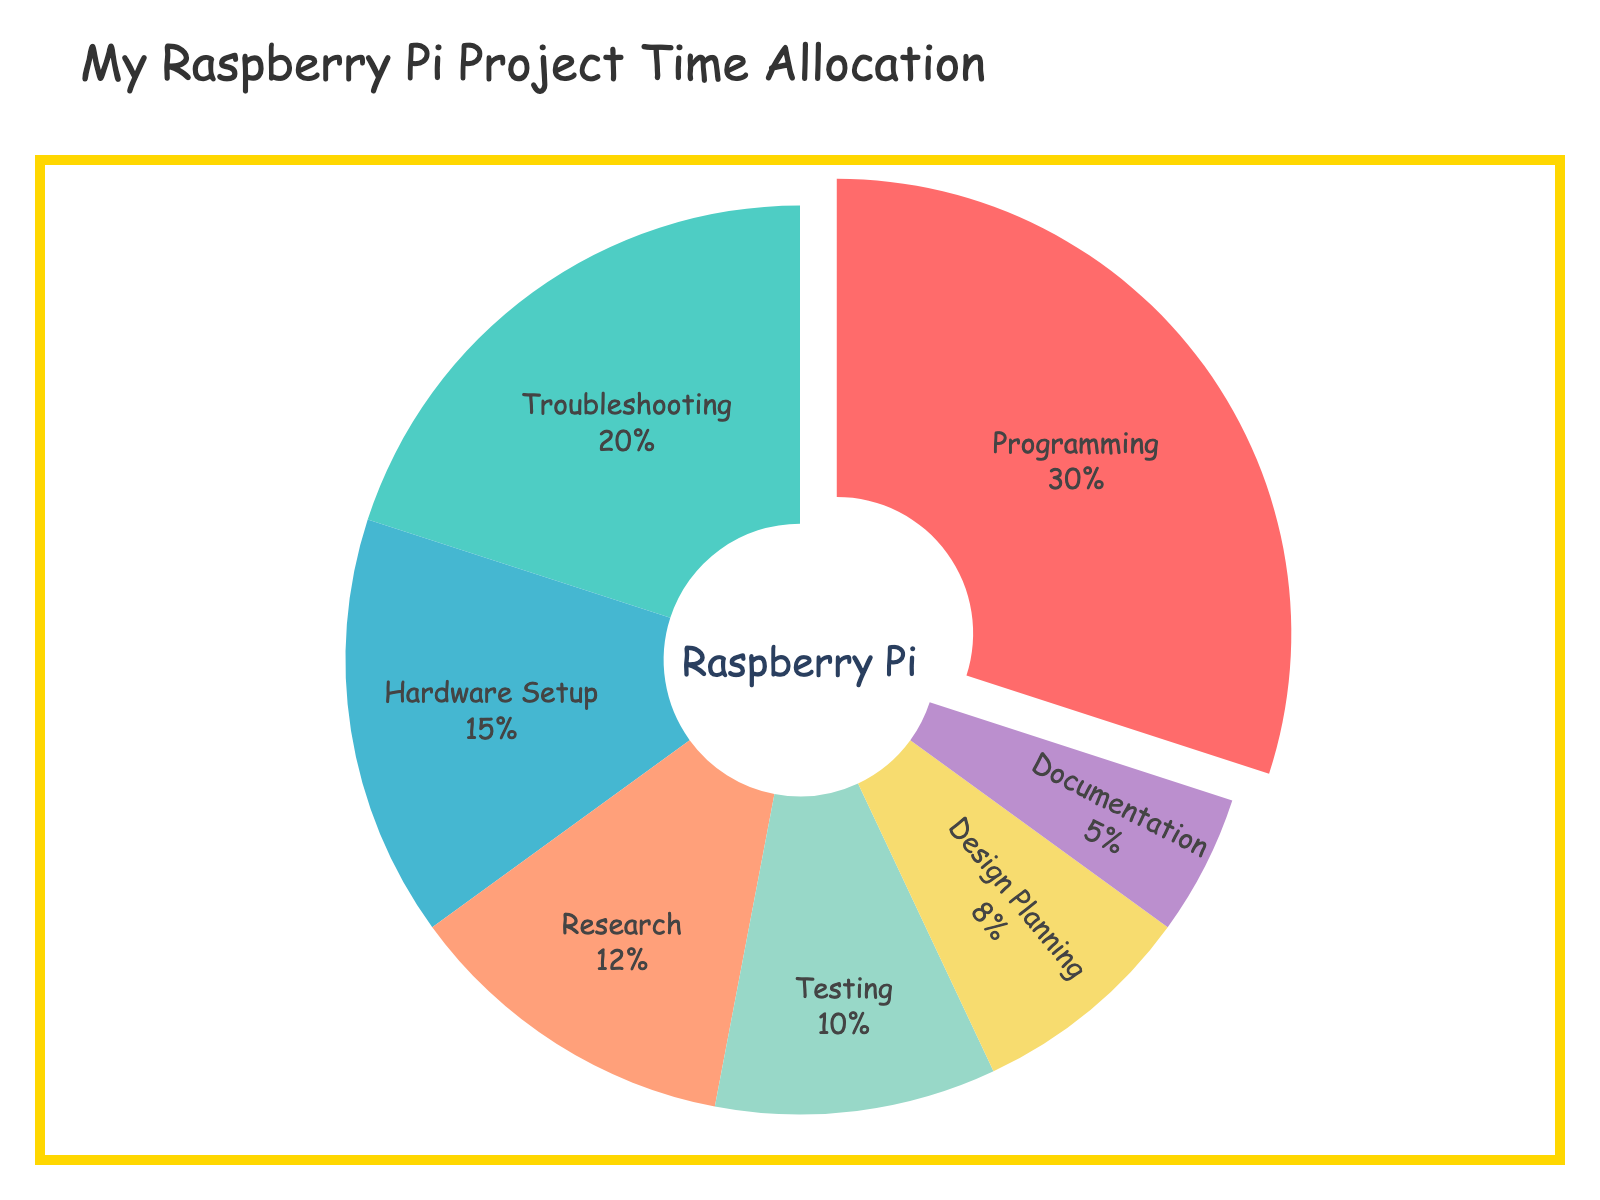Which category takes up the most time in the Raspberry Pi project? The pie chart shows that "Programming" is the largest slice, taking up the biggest percentage of the pie.
Answer: Programming How much more time is spent on Troubleshooting compared to Documentation? Identify the percentages for Troubleshooting (20%) and Documentation (5%). Subtract the percentage for Documentation from Troubleshooting: 20% - 5% = 15%.
Answer: 15% What percentage of time is spent on Testing and Research combined? Find the percentages for Testing (10%) and Research (12%). Add these percentages together: 10% + 12% = 22%.
Answer: 22% Which category has the smallest slice in the pie chart? Observe the slices and identify the smallest one, which is "Documentation" with 5%.
Answer: Documentation How does the percentage of time spent on Hardware Setup compare to the time spent on Design Planning? The percentage of time spent on Hardware Setup is 15%, while Design Planning is 8%. Since 15% is greater than 8%, more time is spent on Hardware Setup.
Answer: Hardware Setup is greater If the total time spent on the project is 100 hours, how many hours are dedicated to Research? The percentage for Research is 12%. Multiply the total hours (100) by this percentage: 100 * 0.12 = 12.
Answer: 12 What is the difference in time allocation between Programming and Hardware Setup? Identify the percentages for Programming (30%) and Hardware Setup (15%). Subtract the percentage for Hardware Setup from Programming: 30% - 15% = 15%.
Answer: 15% Which two categories combined make up exactly 25% of the total time? Identify percentages that add up to 25%. Design Planning (8%) and Documentation (5%) do not add to 25%. Testing (10%) and Documentation (5%) add to 15%. Therefore, none of the pairs combine to 25%. In fact, If reconsidering, Research (12%) and Design Planning (8%) are closest (but they add up to 20%). No exact pair.
Answer: None If you combined time spent on Documentation and Design Planning, what fraction of the total time does it represent? Find the percentages for Documentation (5%) and Design Planning (8%). Add these: 5% + 8% = 13%. Therefore, 13% of total time is combined. Convert to fraction: 13/100.
Answer: 13/100 